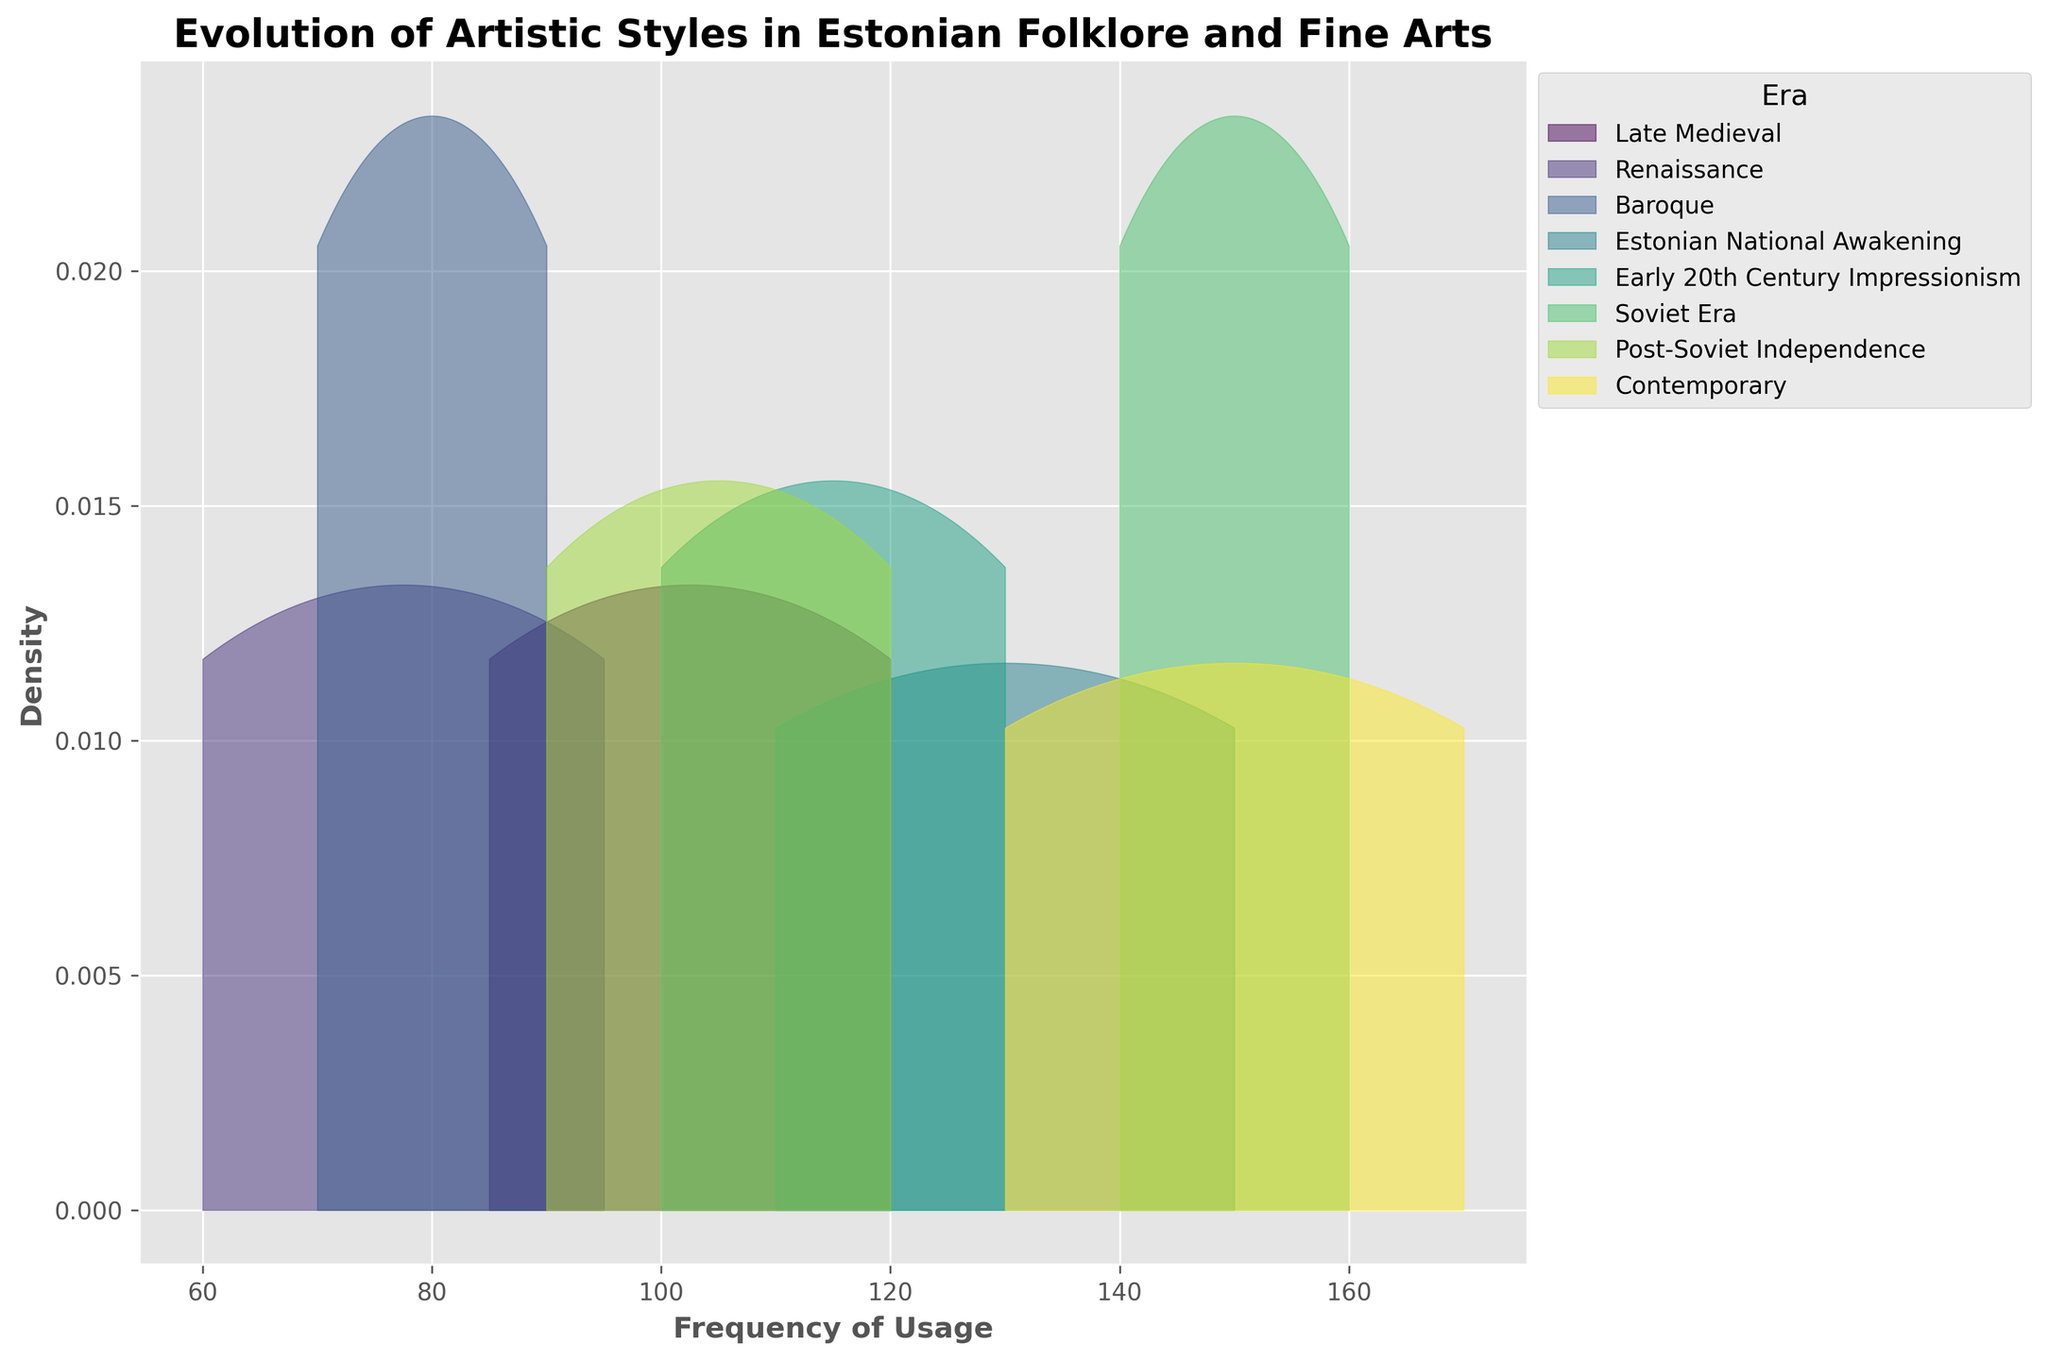What's the title of the figure? The title of a figure is typically located at the top, often in a larger or bold font. In this case, it reads 'Evolution of Artistic Styles in Estonian Folklore and Fine Arts'.
Answer: Evolution of Artistic Styles in Estonian Folklore and Fine Arts What does the x-axis represent in the figure? The x-axis usually labels a measurable quantity. Here, it is labeled as 'Frequency of Usage', indicating how often different artistic styles have been used across eras.
Answer: Frequency of Usage What artistic style shows the highest frequency of usage in the "Soviet Era"? By examining the areas under the curves for the Soviet Era section, we can identify that 'Socialist Realism' peaks higher than 'Industrial Scenes', indicating a higher frequency of usage.
Answer: Socialist Realism Which era has the broadest range of frequency usage values? To determine this, observe the width of the density plots along the x-axis. The contemporary era has a wide range from low to high frequency values when compared to other eras, indicating a broad range.
Answer: Contemporary Comparing the Renaissance and Baroque eras, which one has more evenly distributed artistic styles across frequencies? The Renaissance density curves appear more evenly spread across frequencies, whereas Baroque's density curves are more peaked, indicating concentration at certain frequency values.
Answer: Renaissance For Traditional Folk Art during the Estonian National Awakening, is its frequency higher or lower than Nature Themes during Early 20th Century Impressionism? By aligning the density curves of Traditional Folk Art with that of Nature Themes, it is evident that Traditional Folk Art has a higher frequency peak.
Answer: Higher What is the primary color associated with the Baroque era curve in the figure? Each era in the figure is coded with a distinct color. The Baroque era is represented by a certain color that can be observed on the figure.
Answer: Green (or the specific color as shown in the figure) At approximately what frequency range do 'Multicultural Fusion' densities peak in the Contemporary era? By examining the x-axis range where the peak of the 'Multicultural Fusion' occurs, we can estimate that it peaks around the frequency range of 120-140.
Answer: 120-140 Which era shows the highest density of usage for Rural Life themes? The Early 20th Century Impressionism has the highest density peak for Rural Life themes, evident from the height of the density curve in its respective era.
Answer: Early 20th Century Impressionism 